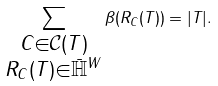Convert formula to latex. <formula><loc_0><loc_0><loc_500><loc_500>\sum _ { \substack { C \in \mathcal { C } ( T ) \\ R _ { C } ( T ) \in \bar { \mathbb { H } } ^ { W } } } \beta ( R _ { C } ( T ) ) = | T | .</formula> 